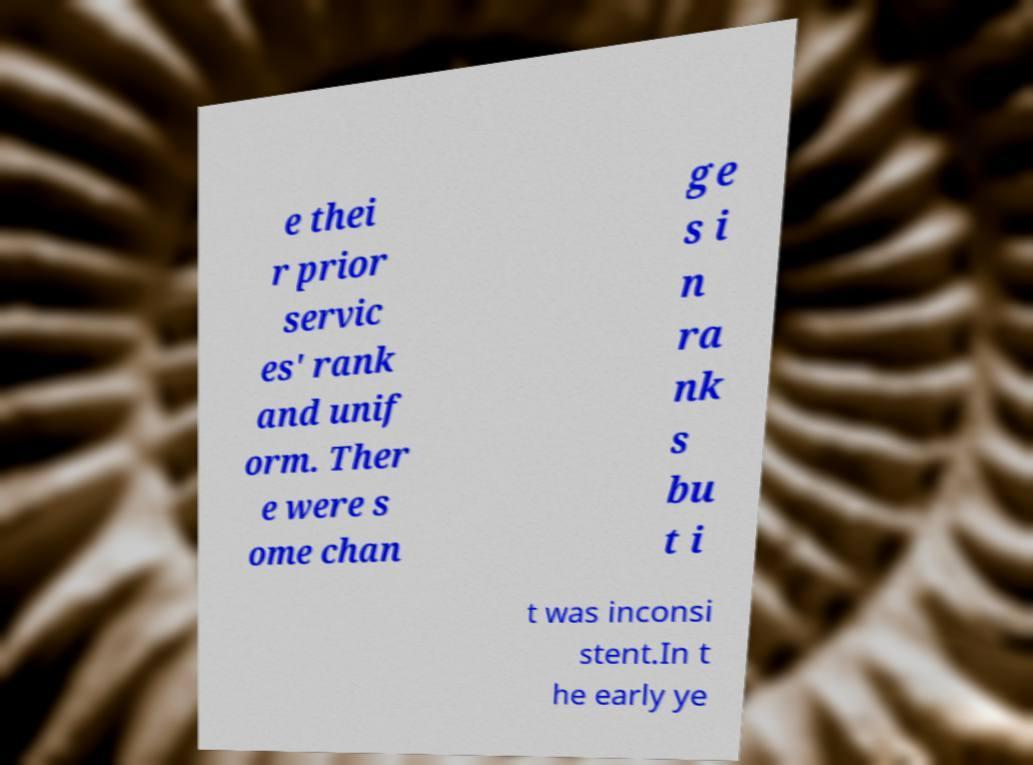Please read and relay the text visible in this image. What does it say? e thei r prior servic es' rank and unif orm. Ther e were s ome chan ge s i n ra nk s bu t i t was inconsi stent.In t he early ye 